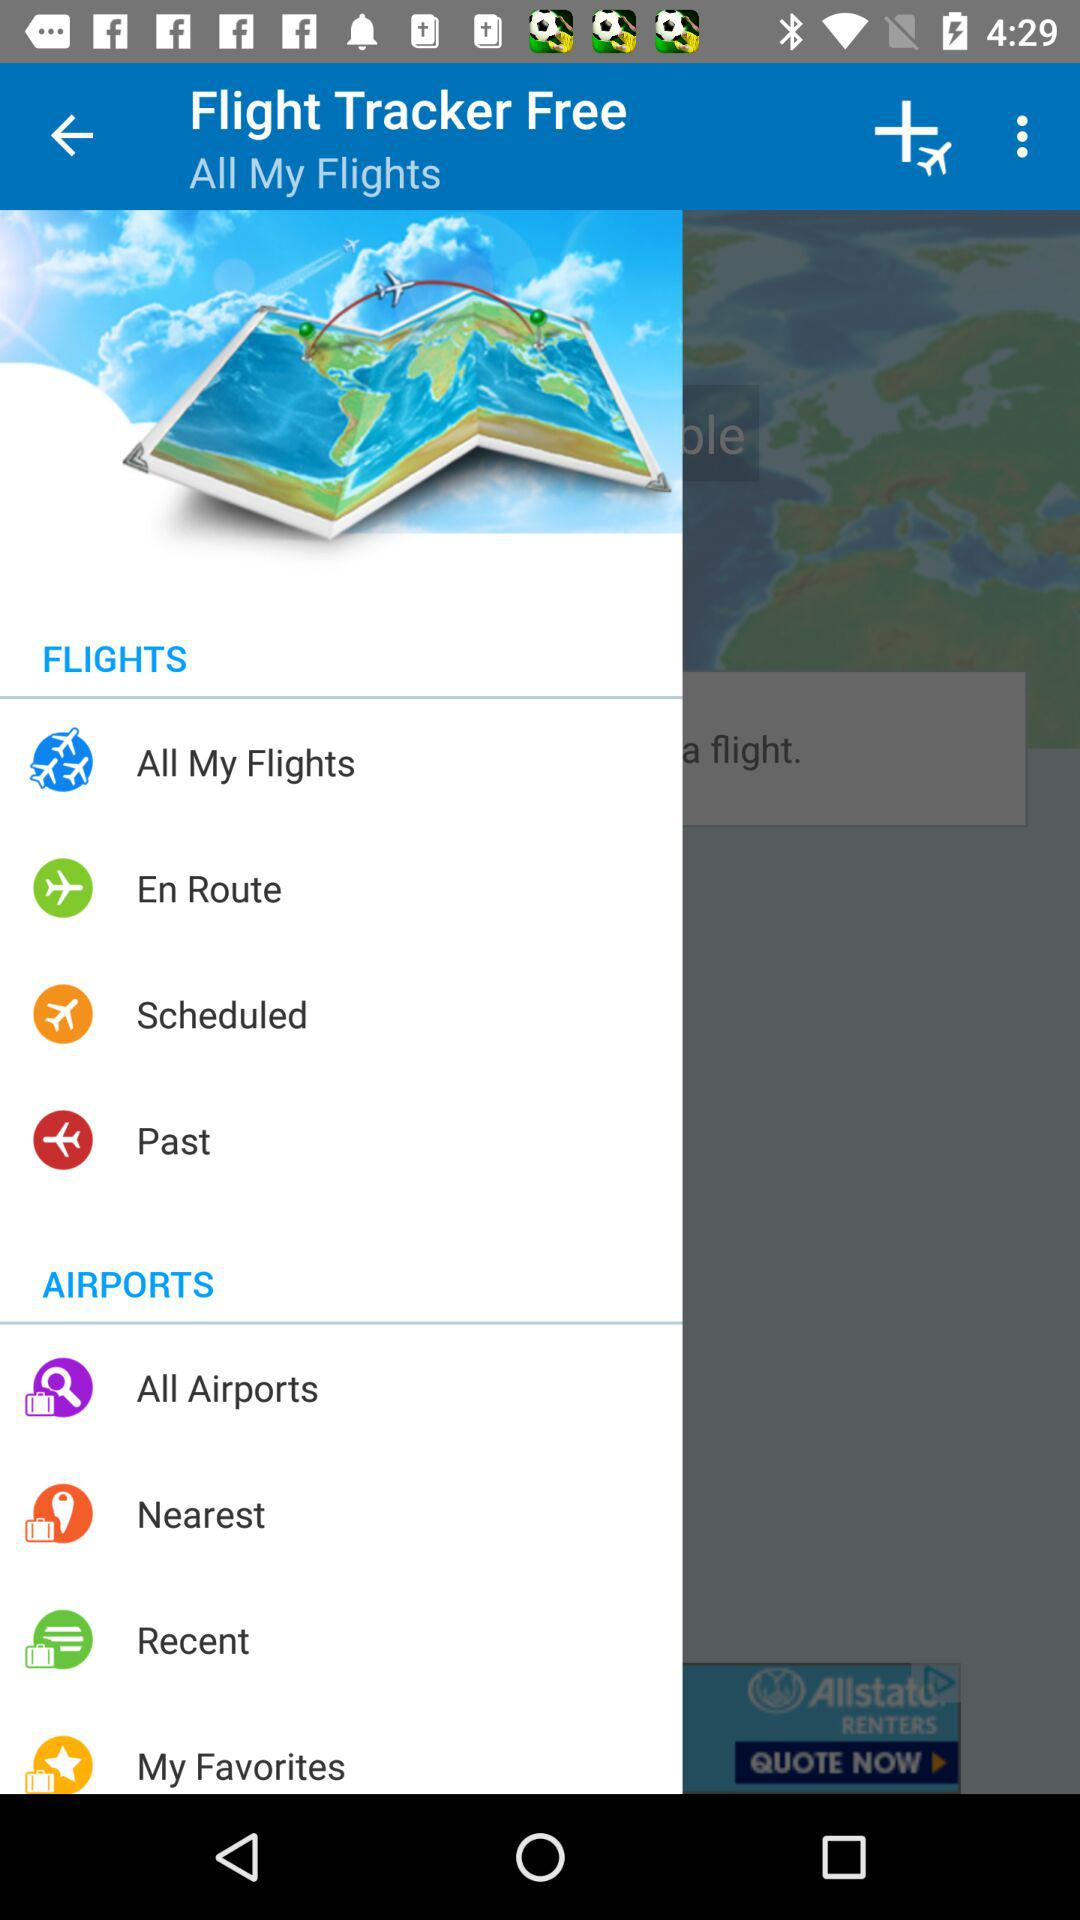How many items are in the 'Airports' section?
Answer the question using a single word or phrase. 4 